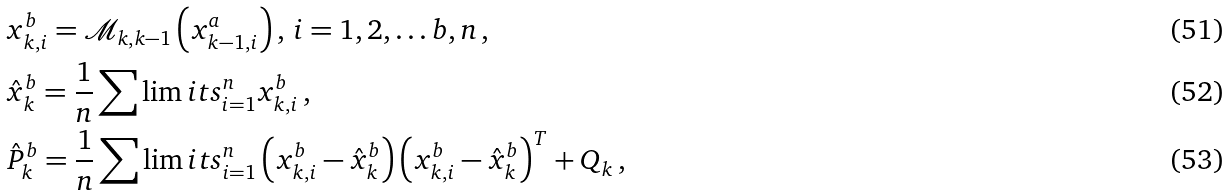<formula> <loc_0><loc_0><loc_500><loc_500>& x ^ { b } _ { k , i } = \mathcal { M } _ { k , k - 1 } \left ( x _ { k - 1 , i } ^ { a } \right ) , \, i = 1 , 2 , \dots b , n \, , \\ & \hat { x } _ { k } ^ { b } = \frac { 1 } { n } \sum \lim i t s _ { i = 1 } ^ { n } x ^ { b } _ { k , i } \, , \\ & \hat { P } _ { k } ^ { b } = \frac { 1 } { n } \sum \lim i t s _ { i = 1 } ^ { n } \left ( x ^ { b } _ { k , i } - \hat { x } _ { k } ^ { b } \right ) \left ( x ^ { b } _ { k , i } - \hat { x } _ { k } ^ { b } \right ) ^ { T } + Q _ { k } \, ,</formula> 